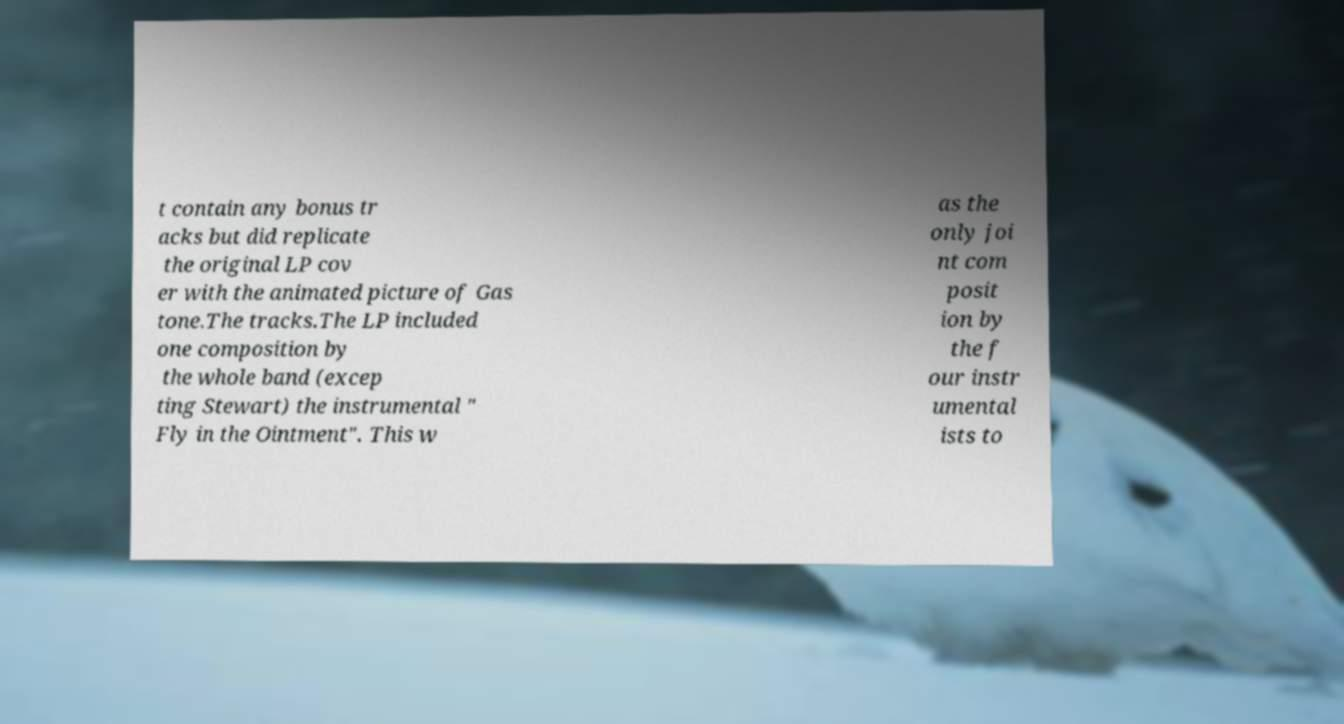For documentation purposes, I need the text within this image transcribed. Could you provide that? t contain any bonus tr acks but did replicate the original LP cov er with the animated picture of Gas tone.The tracks.The LP included one composition by the whole band (excep ting Stewart) the instrumental " Fly in the Ointment". This w as the only joi nt com posit ion by the f our instr umental ists to 